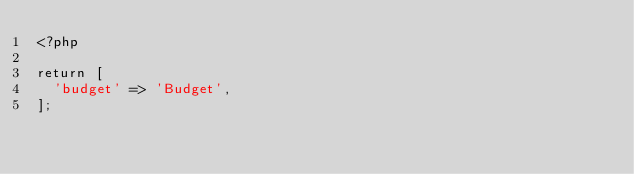<code> <loc_0><loc_0><loc_500><loc_500><_PHP_><?php

return [
  'budget' => 'Budget',
];</code> 